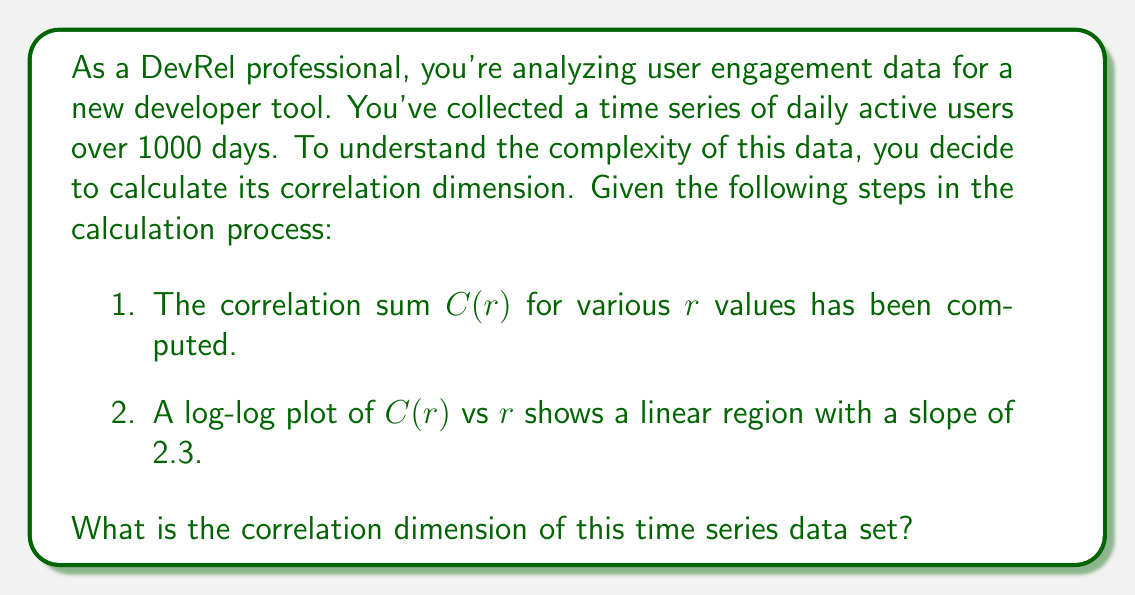Can you answer this question? To calculate the correlation dimension, we follow these steps:

1. The correlation sum $C(r)$ is defined as:

   $$C(r) = \frac{2}{N(N-1)} \sum_{i=1}^{N} \sum_{j=i+1}^{N} \Theta(r - ||x_i - x_j||)$$

   where $N$ is the number of points, $\Theta$ is the Heaviside step function, and $||x_i - x_j||$ is the distance between points $i$ and $j$.

2. For small $r$, $C(r)$ scales as:

   $$C(r) \propto r^D$$

   where $D$ is the correlation dimension.

3. Taking logarithms of both sides:

   $$\log(C(r)) \propto D \log(r)$$

4. This results in a linear relationship on a log-log plot of $C(r)$ vs $r$, where the slope of the linear region is the correlation dimension $D$.

5. In this case, we're given that the slope of the linear region in the log-log plot is 2.3.

Therefore, the correlation dimension $D$ is equal to the slope of this linear region, which is 2.3.
Answer: 2.3 